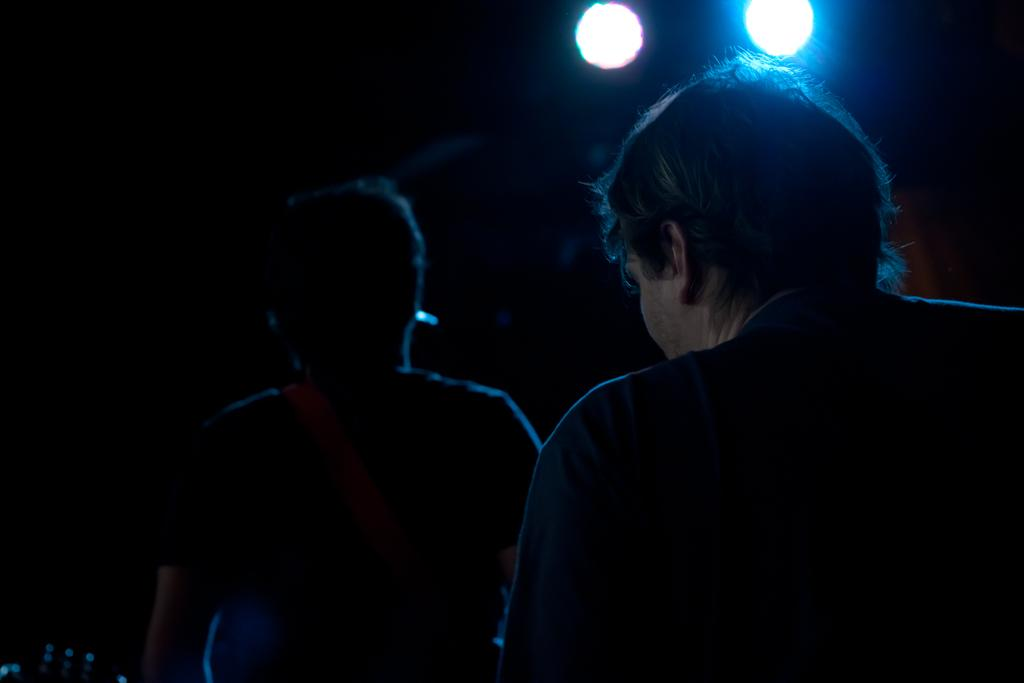How many people are in the image? There are two people standing in the image. What can be seen at the top of the image? There are spotlights at the top of the image. What is the color of the background in the image? The background of the image is dark. What type of ring can be seen on the mouth of one of the people in the image? There is no ring or mouth visible on any of the people in the image. What kind of shade is being used by the people in the image? There is no shade present in the image; it is not mentioned in the provided facts. 